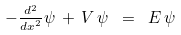Convert formula to latex. <formula><loc_0><loc_0><loc_500><loc_500>- \frac { _ { d ^ { 2 } } } { ^ { d x ^ { 2 } } } \psi \, + \, V \, \psi \ = \ E \, \psi</formula> 